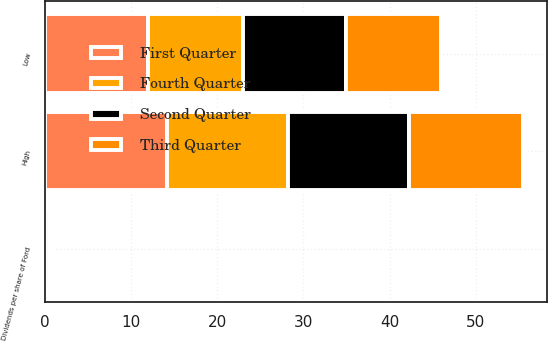Convert chart. <chart><loc_0><loc_0><loc_500><loc_500><stacked_bar_chart><ecel><fcel>High<fcel>Low<fcel>Dividends per share of Ford<nl><fcel>Fourth Quarter<fcel>14<fcel>11.02<fcel>0.4<nl><fcel>First Quarter<fcel>14.22<fcel>12<fcel>0.15<nl><fcel>Second Quarter<fcel>14.04<fcel>11.9<fcel>0.15<nl><fcel>Third Quarter<fcel>13.2<fcel>11.07<fcel>0.15<nl></chart> 